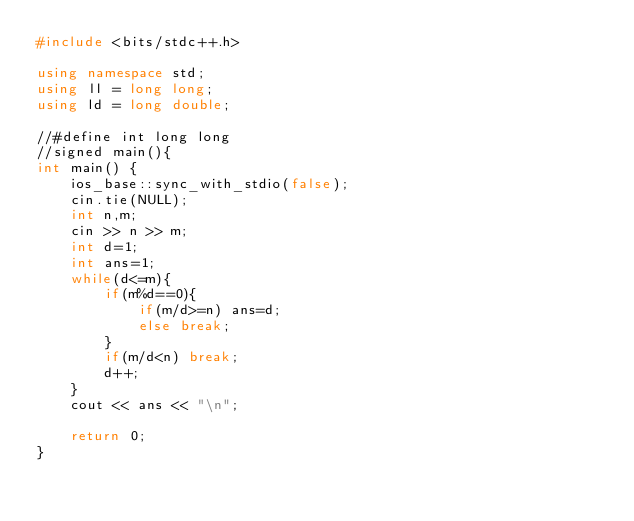Convert code to text. <code><loc_0><loc_0><loc_500><loc_500><_C++_>#include <bits/stdc++.h>

using namespace std;
using ll = long long;
using ld = long double;

//#define int long long
//signed main(){
int main() {
    ios_base::sync_with_stdio(false);
    cin.tie(NULL);
    int n,m;
    cin >> n >> m;
    int d=1;
    int ans=1;
    while(d<=m){
        if(m%d==0){
            if(m/d>=n) ans=d;
            else break;
        }
        if(m/d<n) break;
        d++;
    }
    cout << ans << "\n";

    return 0;
}</code> 